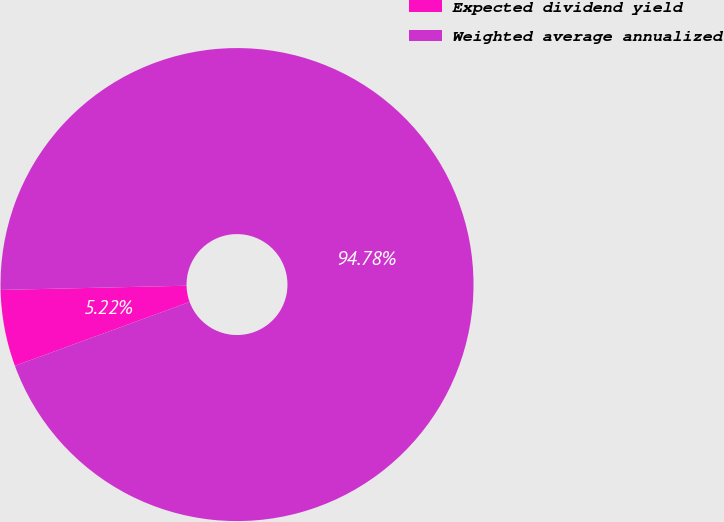Convert chart. <chart><loc_0><loc_0><loc_500><loc_500><pie_chart><fcel>Expected dividend yield<fcel>Weighted average annualized<nl><fcel>5.22%<fcel>94.78%<nl></chart> 